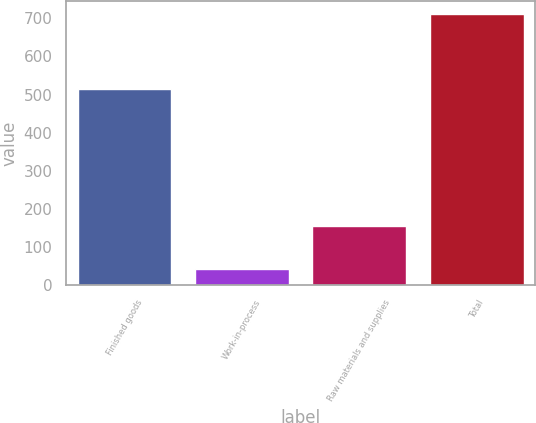<chart> <loc_0><loc_0><loc_500><loc_500><bar_chart><fcel>Finished goods<fcel>Work-in-process<fcel>Raw materials and supplies<fcel>Total<nl><fcel>514<fcel>42<fcel>155<fcel>711<nl></chart> 